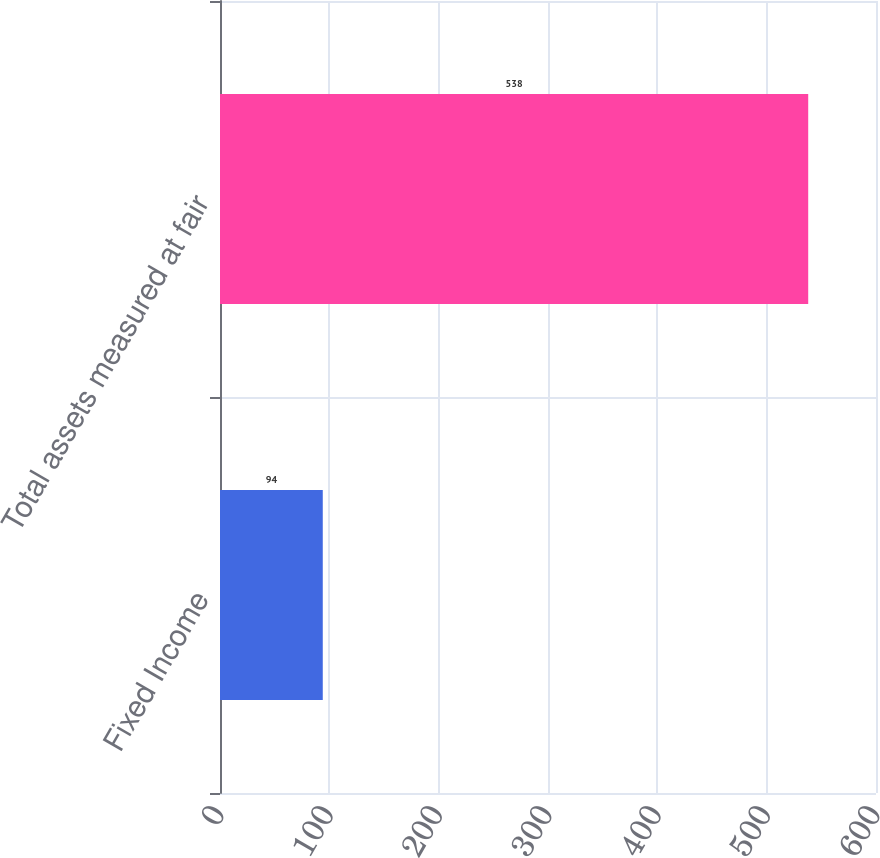Convert chart. <chart><loc_0><loc_0><loc_500><loc_500><bar_chart><fcel>Fixed Income<fcel>Total assets measured at fair<nl><fcel>94<fcel>538<nl></chart> 